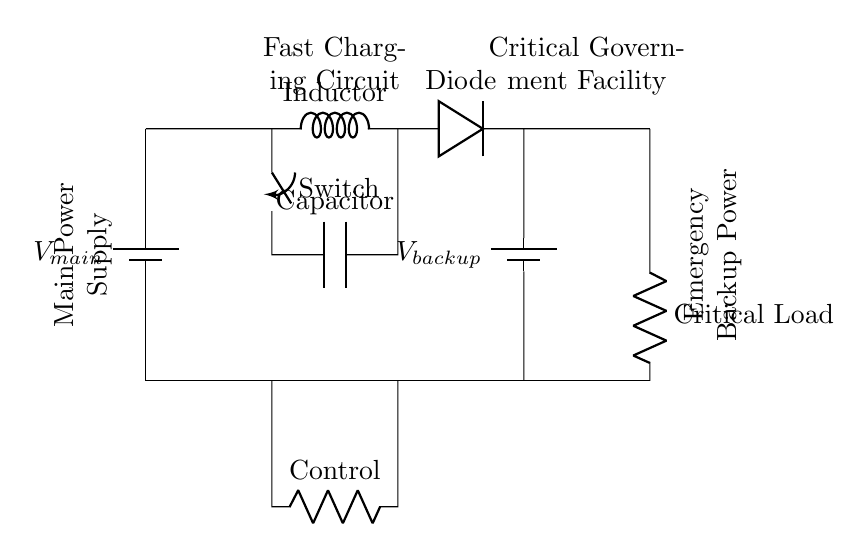What is the main power source in this circuit? The main power source is labeled as V main, which is a battery supplying power to the circuit.
Answer: V main What component acts as a control element in this circuit? The control element in this circuit is represented by the resistor labeled as Control.
Answer: Control Which component provides emergency backup power? The emergency backup power is provided by the battery labeled as V backup.
Answer: V backup How many energy storage elements are shown in the circuit? There are two energy storage elements: one inductor and one capacitor labeled as Inductor and Capacitor, respectively.
Answer: Two What role does the diode play in this circuit? The diode, labeled as Diode, allows current to flow from the fast charging circuit to the emergency backup battery while preventing backflow.
Answer: Prevents backflow What is the purpose of the fast-charging circuit? The fast-charging circuit is designed to quickly charge the emergency backup battery from the main power source, enabling rapid readiness for use.
Answer: Quick charging What type of load is connected at the output of this circuit? The output of the circuit is connected to a critical load, which is vital for government facilities.
Answer: Critical Load 